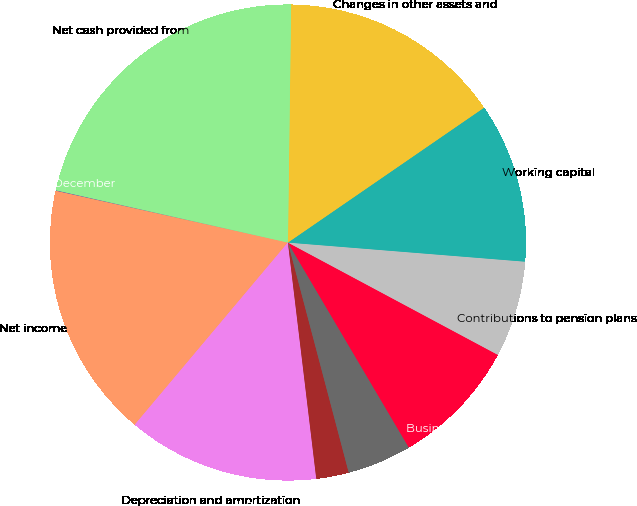Convert chart to OTSL. <chart><loc_0><loc_0><loc_500><loc_500><pie_chart><fcel>For the years ended December<fcel>Net income<fcel>Depreciation and amortization<fcel>Stock-based compensation and<fcel>Deferred income taxes<fcel>Business realignment and<fcel>Contributions to pension plans<fcel>Working capital<fcel>Changes in other assets and<fcel>Net cash provided from<nl><fcel>0.04%<fcel>17.36%<fcel>13.03%<fcel>2.21%<fcel>4.37%<fcel>8.7%<fcel>6.54%<fcel>10.87%<fcel>15.2%<fcel>21.69%<nl></chart> 